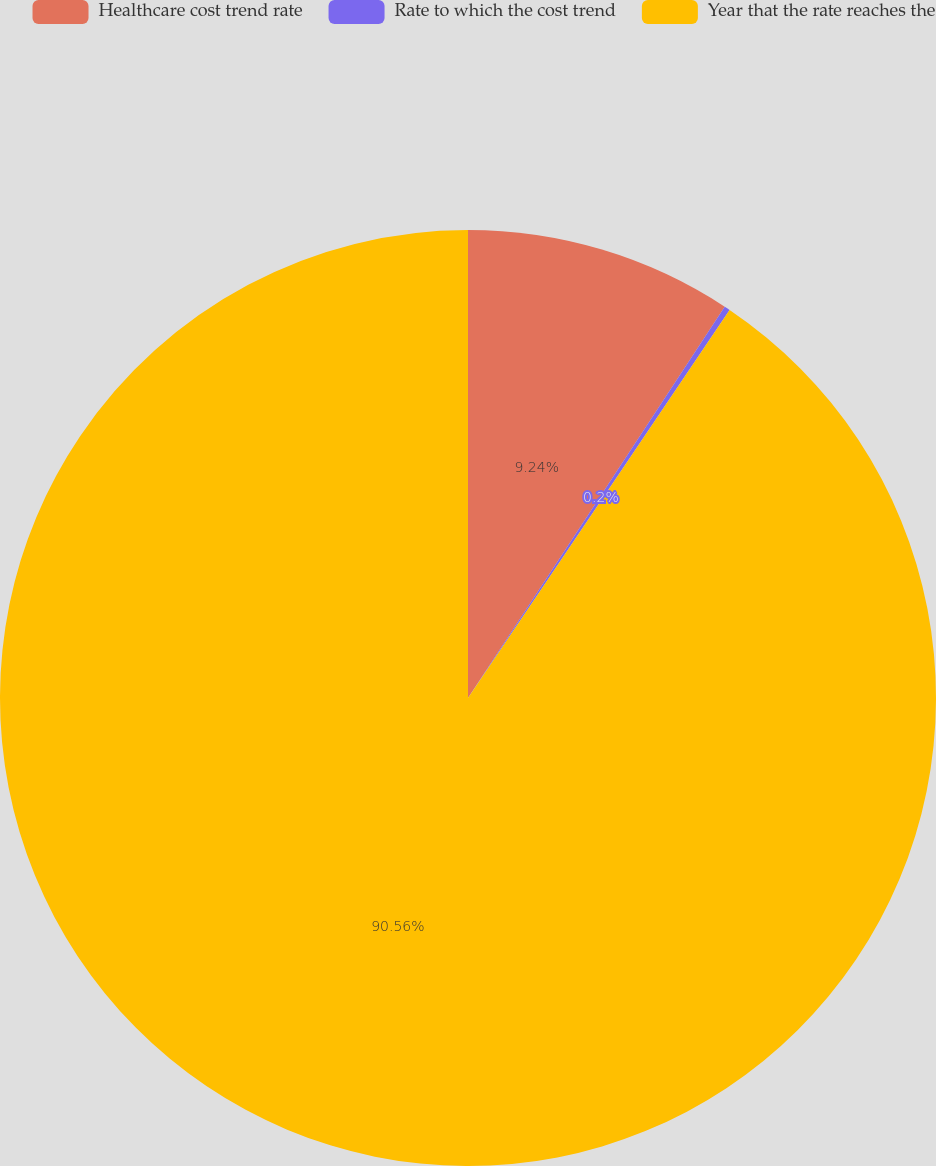<chart> <loc_0><loc_0><loc_500><loc_500><pie_chart><fcel>Healthcare cost trend rate<fcel>Rate to which the cost trend<fcel>Year that the rate reaches the<nl><fcel>9.24%<fcel>0.2%<fcel>90.56%<nl></chart> 